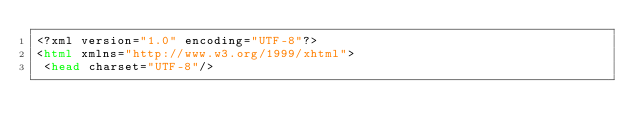Convert code to text. <code><loc_0><loc_0><loc_500><loc_500><_HTML_><?xml version="1.0" encoding="UTF-8"?>
<html xmlns="http://www.w3.org/1999/xhtml">
 <head charset="UTF-8"/></code> 